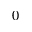<formula> <loc_0><loc_0><loc_500><loc_500>0</formula> 